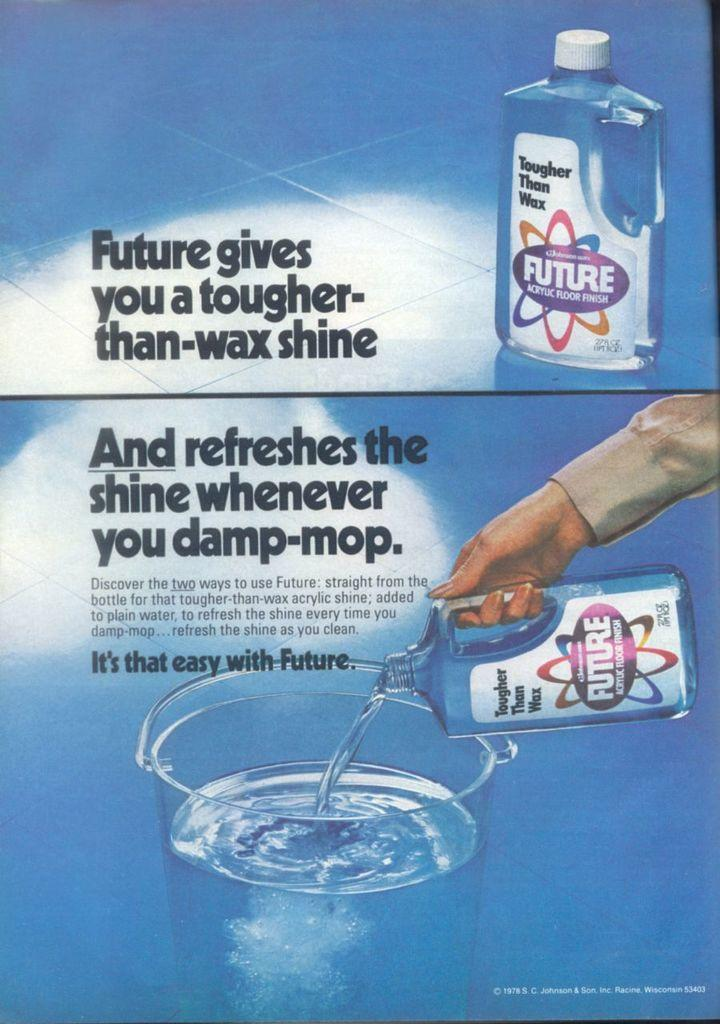What is the main subject of the image? The main subject of the image is an advertisement. What type of card is being used to scrape the ice off the building in the image? There is no card, ice, or building present in the image. 